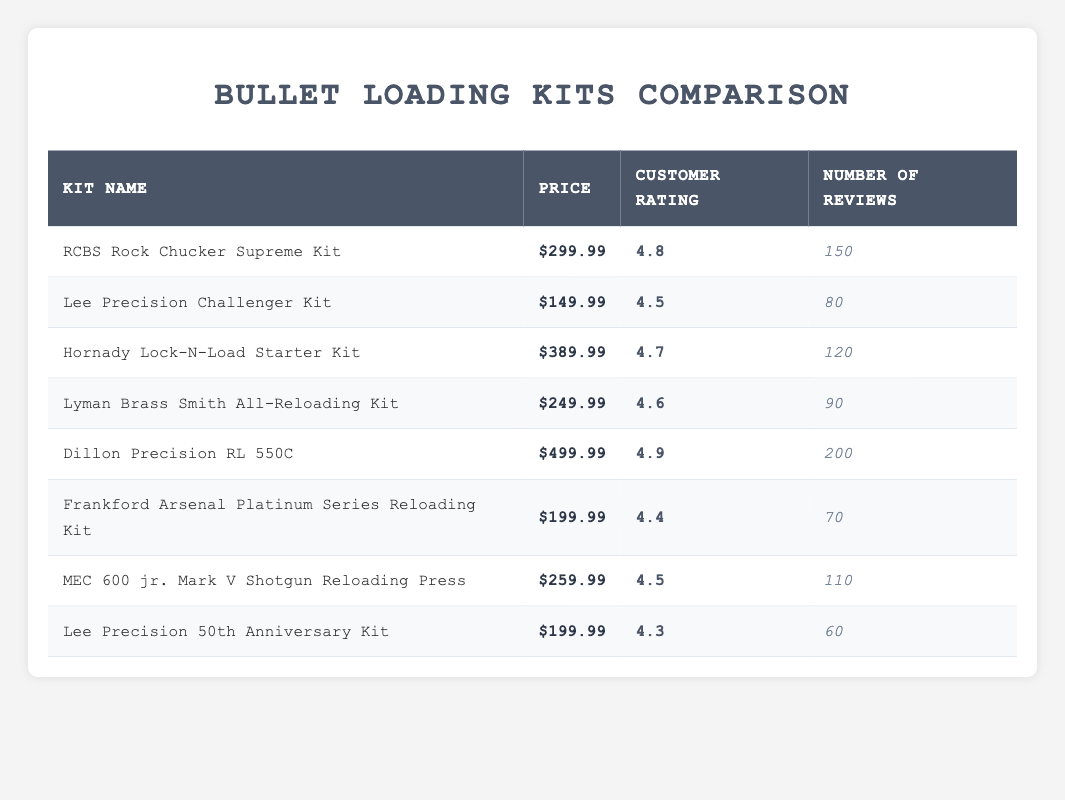What is the price of the Dillon Precision RL 550C kit? The Dillon Precision RL 550C kit is listed in the table with a price of $499.99. There are no other prices needed to reference for this specific question.
Answer: $499.99 Which bullet loading kit has the highest customer rating? The table indicates that the Dillon Precision RL 550C has the highest customer rating at 4.9. I can find this by comparing the customer ratings of all the kits listed.
Answer: Dillon Precision RL 550C How many reviews does the Lee Precision Challenger Kit have? From the table, the Lee Precision Challenger Kit has 80 reviews listed under the "Number of Reviews" column. This information can be directly retrieved from the table without additional calculations.
Answer: 80 What is the average customer rating of all the kits listed? To find the average, I will sum up the customer ratings of all kits: (4.8 + 4.5 + 4.7 + 4.6 + 4.9 + 4.4 + 4.5 + 4.3) = 36.7. Then, I divide by the total number of kits, which is 8: 36.7 / 8 = 4.5875, rounded to two decimal places gives 4.59.
Answer: 4.59 Is it true that the Frankford Arsenal Platinum Series Reloading Kit has a customer rating of 4.4? Yes, according to the table, the Frankford Arsenal Platinum Series Reloading Kit is explicitly listed with a customer rating of 4.4, so this statement is true.
Answer: Yes Which kit has a higher number of reviews, the MEC 600 jr. Mark V Shotgun Reloading Press or the Hornady Lock-N-Load Starter Kit? The MEC 600 jr. Mark V has 110 reviews while the Hornady Lock-N-Load Starter Kit has 120 reviews. Comparing these two values shows that the Hornady Lock-N-Load Starter Kit has a higher number of reviews.
Answer: Hornady Lock-N-Load Starter Kit How much cheaper is the Lee Precision 50th Anniversary Kit compared to the Dillon Precision RL 550C? The price of the Lee Precision 50th Anniversary Kit is $199.99 and the Dillon Precision RL 550C is $499.99. To find the difference, I subtract the former from the latter: $499.99 - $199.99 = $300.00.
Answer: $300.00 Is the average price of the kits above or below $300? To calculate the average price, I will sum all the prices: (299.99 + 149.99 + 389.99 + 249.99 + 499.99 + 199.99 + 259.99 + 199.99) = 1839.92, then divide by the number of kits (8): 1839.92 / 8 = $229.99. Since $229.99 is less than $300, the average price is below $300.
Answer: Below $300 Which kit has the lowest customer rating? By examining the customer ratings listed in the table, the Lee Precision 50th Anniversary Kit has the lowest rating of 4.3. This can be determined by finding the lowest value in the "Customer Rating" column.
Answer: Lee Precision 50th Anniversary Kit 